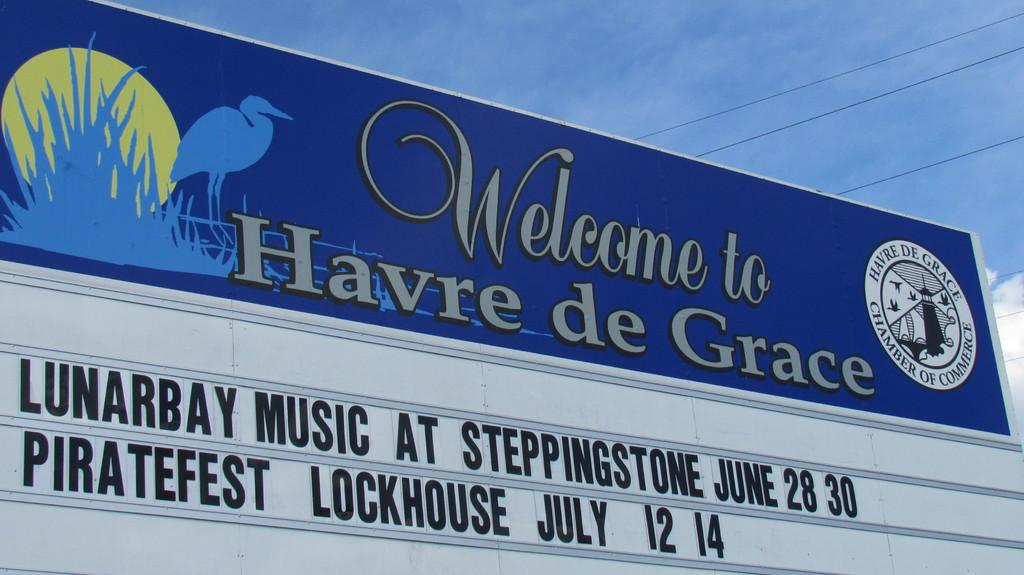Provide a one-sentence caption for the provided image. A church sign advertises for Piratefest Lockhouse in July. 